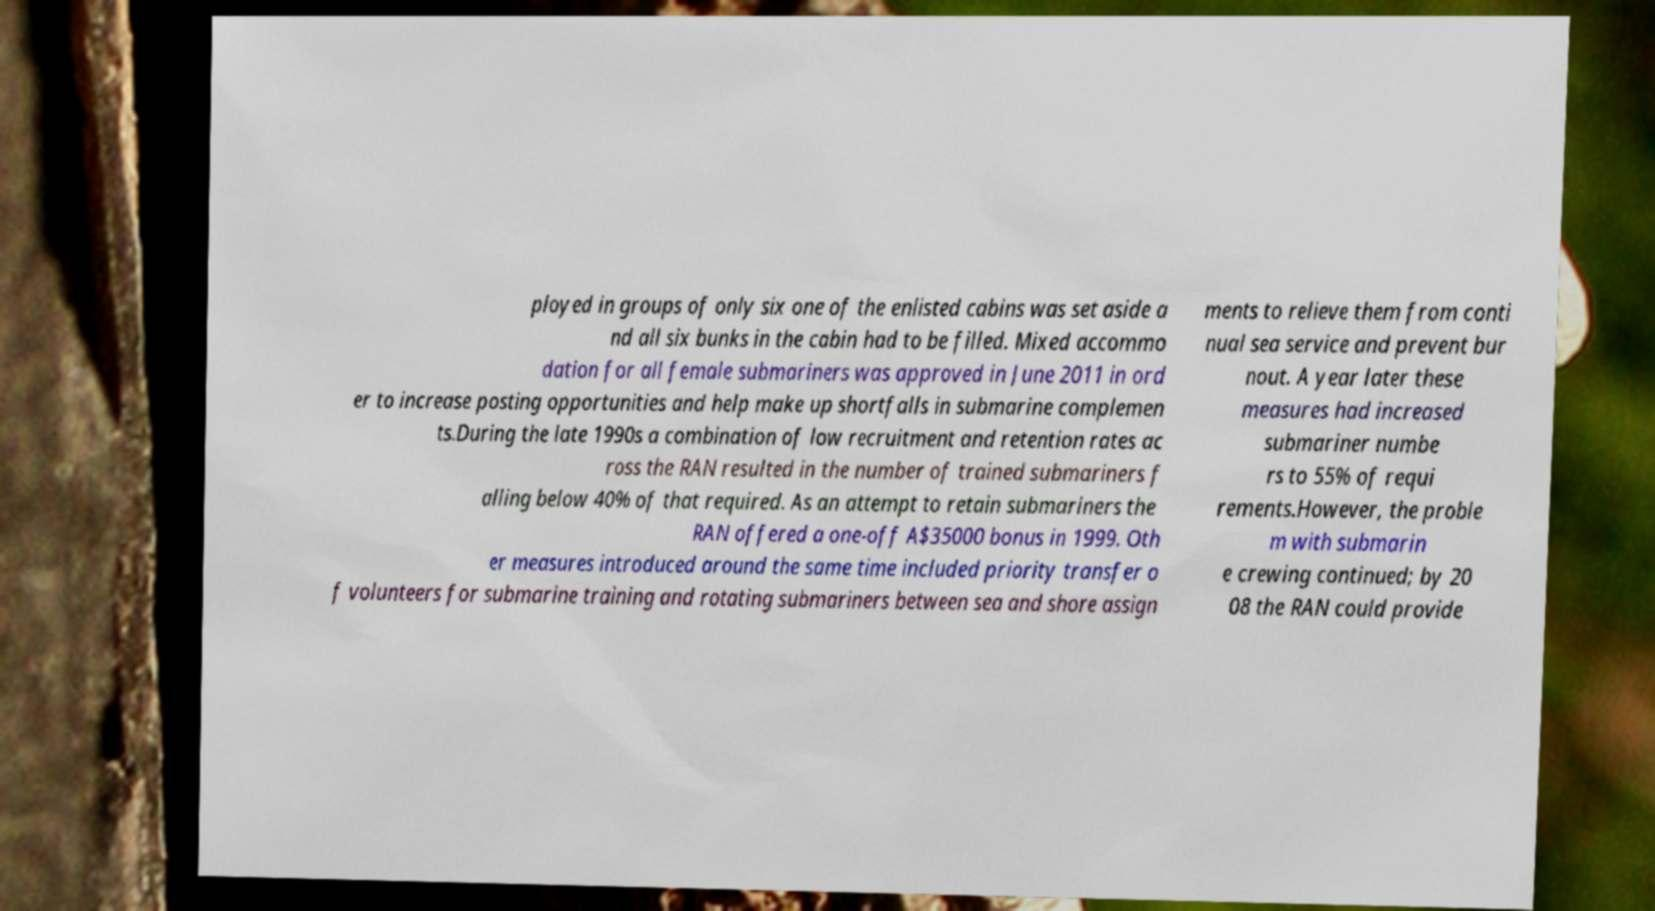Can you read and provide the text displayed in the image?This photo seems to have some interesting text. Can you extract and type it out for me? ployed in groups of only six one of the enlisted cabins was set aside a nd all six bunks in the cabin had to be filled. Mixed accommo dation for all female submariners was approved in June 2011 in ord er to increase posting opportunities and help make up shortfalls in submarine complemen ts.During the late 1990s a combination of low recruitment and retention rates ac ross the RAN resulted in the number of trained submariners f alling below 40% of that required. As an attempt to retain submariners the RAN offered a one-off A$35000 bonus in 1999. Oth er measures introduced around the same time included priority transfer o f volunteers for submarine training and rotating submariners between sea and shore assign ments to relieve them from conti nual sea service and prevent bur nout. A year later these measures had increased submariner numbe rs to 55% of requi rements.However, the proble m with submarin e crewing continued; by 20 08 the RAN could provide 